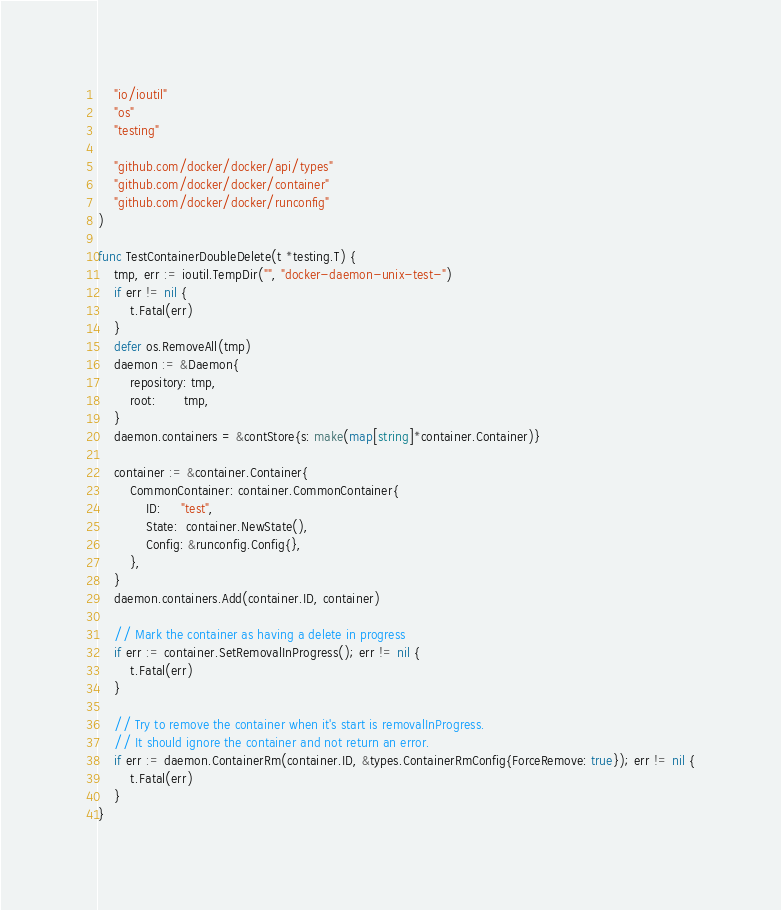Convert code to text. <code><loc_0><loc_0><loc_500><loc_500><_Go_>	"io/ioutil"
	"os"
	"testing"

	"github.com/docker/docker/api/types"
	"github.com/docker/docker/container"
	"github.com/docker/docker/runconfig"
)

func TestContainerDoubleDelete(t *testing.T) {
	tmp, err := ioutil.TempDir("", "docker-daemon-unix-test-")
	if err != nil {
		t.Fatal(err)
	}
	defer os.RemoveAll(tmp)
	daemon := &Daemon{
		repository: tmp,
		root:       tmp,
	}
	daemon.containers = &contStore{s: make(map[string]*container.Container)}

	container := &container.Container{
		CommonContainer: container.CommonContainer{
			ID:     "test",
			State:  container.NewState(),
			Config: &runconfig.Config{},
		},
	}
	daemon.containers.Add(container.ID, container)

	// Mark the container as having a delete in progress
	if err := container.SetRemovalInProgress(); err != nil {
		t.Fatal(err)
	}

	// Try to remove the container when it's start is removalInProgress.
	// It should ignore the container and not return an error.
	if err := daemon.ContainerRm(container.ID, &types.ContainerRmConfig{ForceRemove: true}); err != nil {
		t.Fatal(err)
	}
}
</code> 